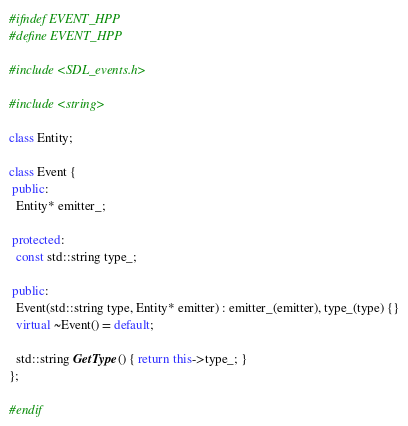Convert code to text. <code><loc_0><loc_0><loc_500><loc_500><_C++_>#ifndef EVENT_HPP
#define EVENT_HPP

#include <SDL_events.h>

#include <string>

class Entity;

class Event {
 public:
  Entity* emitter_;

 protected:
  const std::string type_;

 public:
  Event(std::string type, Entity* emitter) : emitter_(emitter), type_(type) {}
  virtual ~Event() = default;

  std::string GetType() { return this->type_; }
};

#endif
</code> 